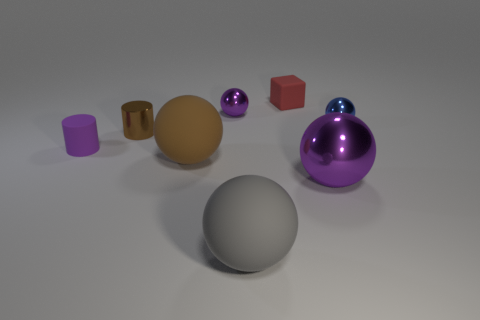How many purple balls must be subtracted to get 1 purple balls? 1 Add 2 small shiny cylinders. How many objects exist? 10 Subtract all cylinders. How many objects are left? 6 Subtract all large brown spheres. How many spheres are left? 4 Subtract all blue balls. How many balls are left? 4 Subtract 0 green blocks. How many objects are left? 8 Subtract 1 blocks. How many blocks are left? 0 Subtract all gray cylinders. Subtract all green spheres. How many cylinders are left? 2 Subtract all gray spheres. How many blue cylinders are left? 0 Subtract all large gray matte cubes. Subtract all tiny purple shiny balls. How many objects are left? 7 